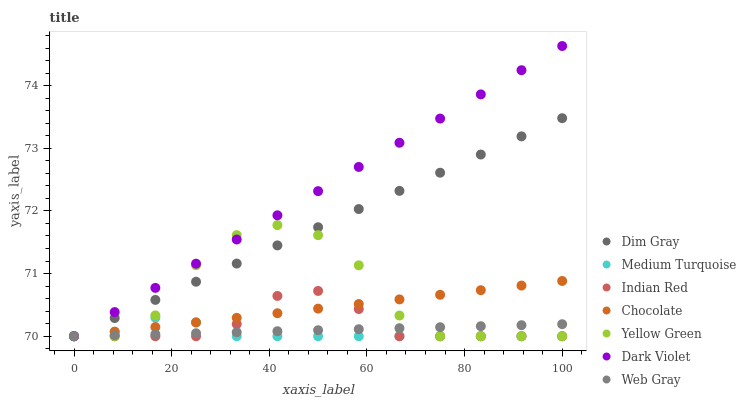Does Medium Turquoise have the minimum area under the curve?
Answer yes or no. Yes. Does Dark Violet have the maximum area under the curve?
Answer yes or no. Yes. Does Dim Gray have the minimum area under the curve?
Answer yes or no. No. Does Dim Gray have the maximum area under the curve?
Answer yes or no. No. Is Dark Violet the smoothest?
Answer yes or no. Yes. Is Yellow Green the roughest?
Answer yes or no. Yes. Is Dim Gray the smoothest?
Answer yes or no. No. Is Dim Gray the roughest?
Answer yes or no. No. Does Medium Turquoise have the lowest value?
Answer yes or no. Yes. Does Dark Violet have the highest value?
Answer yes or no. Yes. Does Dim Gray have the highest value?
Answer yes or no. No. Does Web Gray intersect Indian Red?
Answer yes or no. Yes. Is Web Gray less than Indian Red?
Answer yes or no. No. Is Web Gray greater than Indian Red?
Answer yes or no. No. 